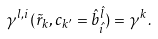Convert formula to latex. <formula><loc_0><loc_0><loc_500><loc_500>\gamma ^ { l , i } ( \tilde { r } _ { k } , c _ { k ^ { \prime } } = \hat { b } _ { \hat { i } } ^ { \hat { l } } ) = \gamma ^ { k } .</formula> 